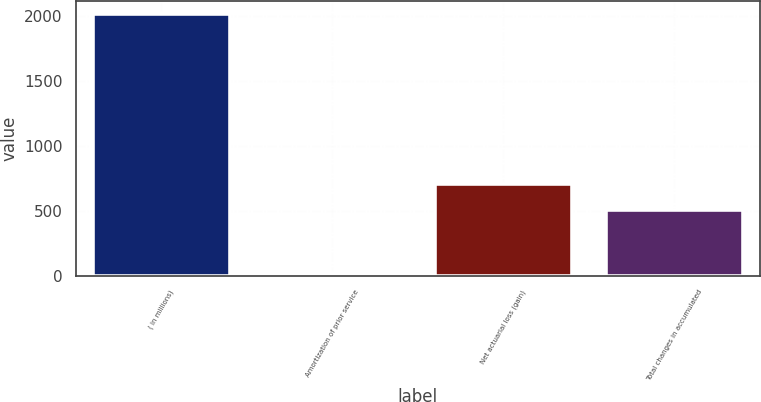<chart> <loc_0><loc_0><loc_500><loc_500><bar_chart><fcel>( in millions)<fcel>Amortization of prior service<fcel>Net actuarial loss (gain)<fcel>Total changes in accumulated<nl><fcel>2014<fcel>19<fcel>707.5<fcel>508<nl></chart> 